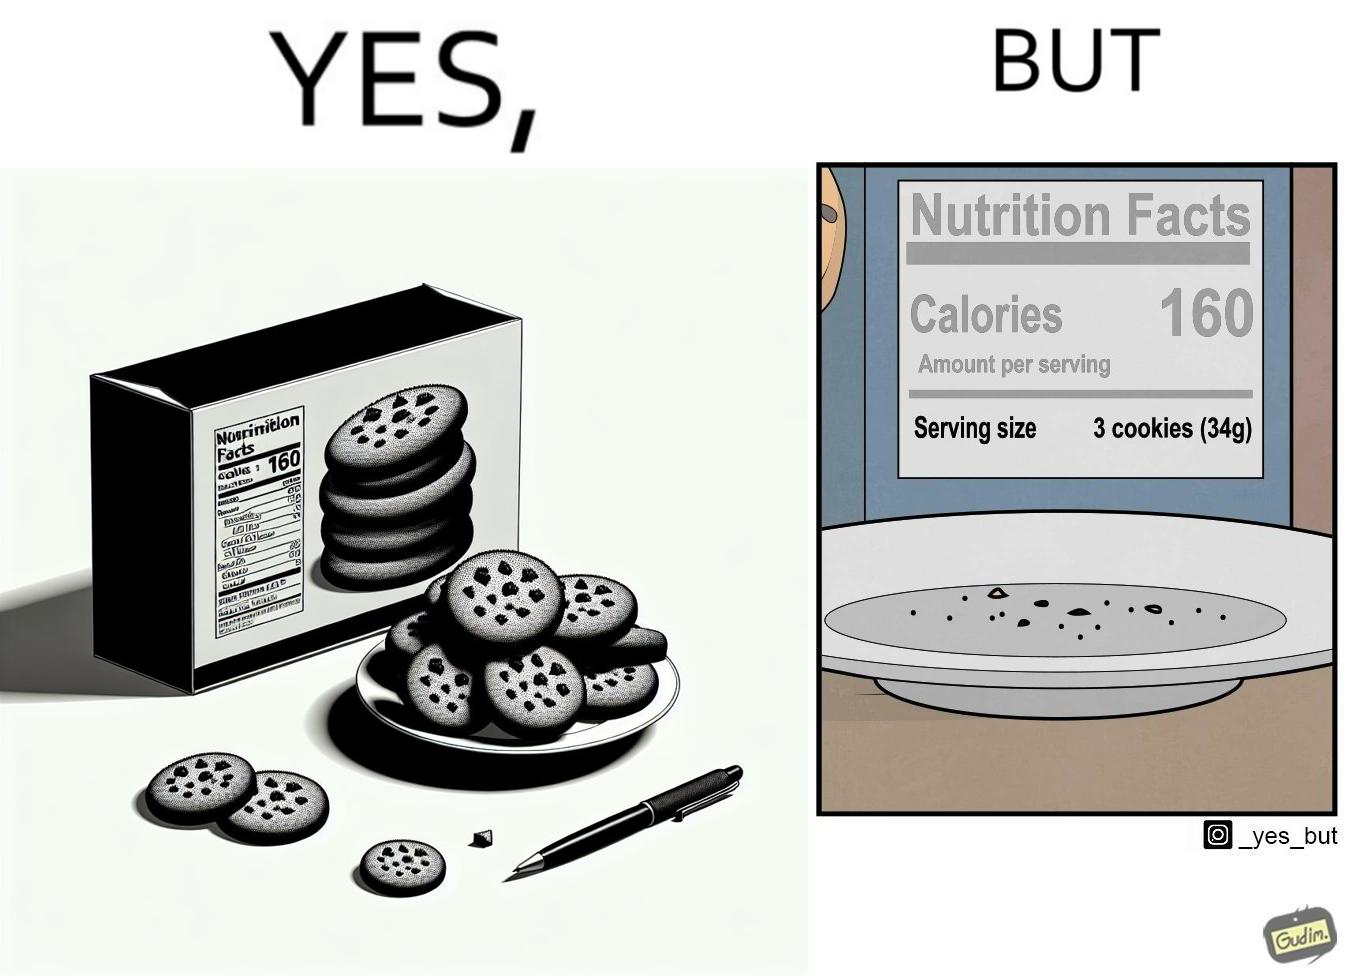Describe what you see in the left and right parts of this image. In the left part of the image: The image shows a plate full of cookies. There is also a cookie box behind the plate. The cookie box behind the plate states number of calories as 160 in the nutrition facts table. In the right part of the image: The image on the right shows an empty plate with the cookie box behind it. The cookie box behind the plate states number of calories as 160 for each serving in the nutrition facts table. It is also mentioned that a serving size is 3 cookies which comes out to be 34 grams. 